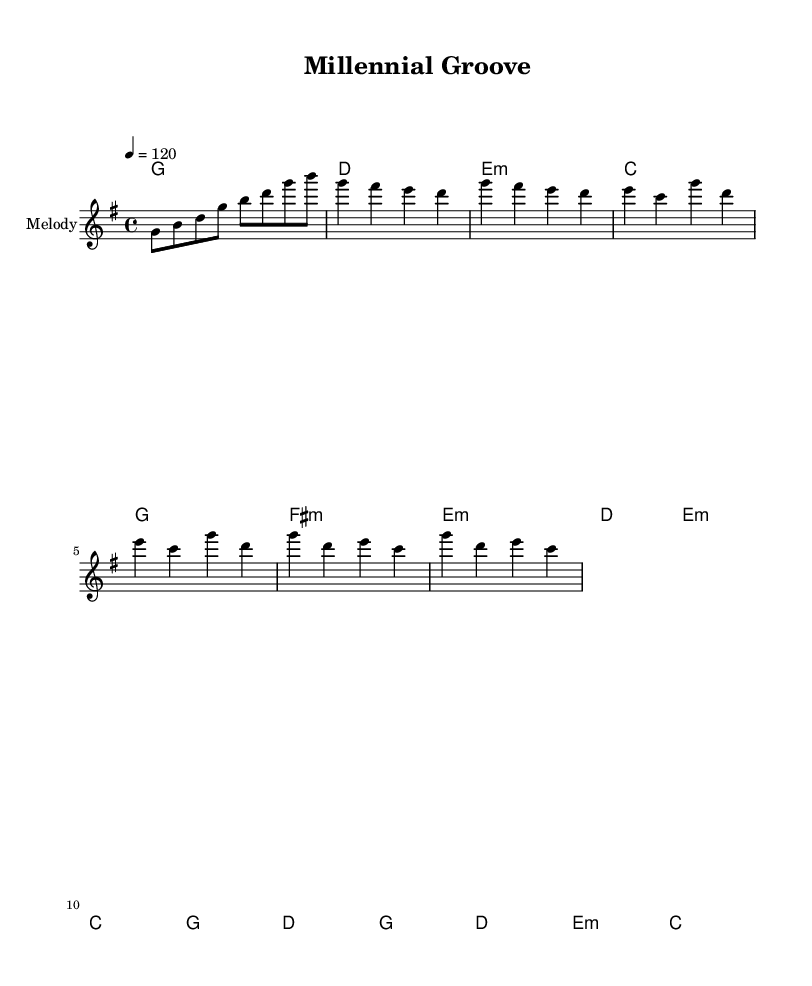What is the key signature of this music? The key signature is G major, which has one sharp (F#). This is indicated at the beginning of the staff.
Answer: G major What is the time signature of this music? The time signature is indicated as 4/4, which is shown at the beginning of the music. This means there are four beats in each measure, and the quarter note gets one beat.
Answer: 4/4 What is the tempo marking for this piece? The tempo marking is given as a quarter note equals 120, which indicates the speed of the piece is moderately fast. This is located right at the beginning of the score.
Answer: 120 How many measures are in the verse section? The verse section consists of two lines (2 measures each) for a total of 4 measures. We can count the measures indicated by the vertical lines separating them.
Answer: 4 Which chords are used in the chorus? The chorus chords are G, D, E minor, and C. These chords are written above the melody in the chord names section.
Answer: G, D, E minor, C What is the structure of the song's sections? The structure is Intro, Verse, Pre-chorus, and Chorus. We determine this by looking at the labeled measures that indicate the different song sections throughout the music.
Answer: Intro, Verse, Pre-chorus, Chorus What mood does the upbeat production suggest for this Fusion style? The upbeat production generally suggests an energetic and fun mood, which is common in hip-hop infused alternative pop genres. This conclusion comes from the combination of lively melodies and rhythmic chord progressions.
Answer: Energetic and fun 